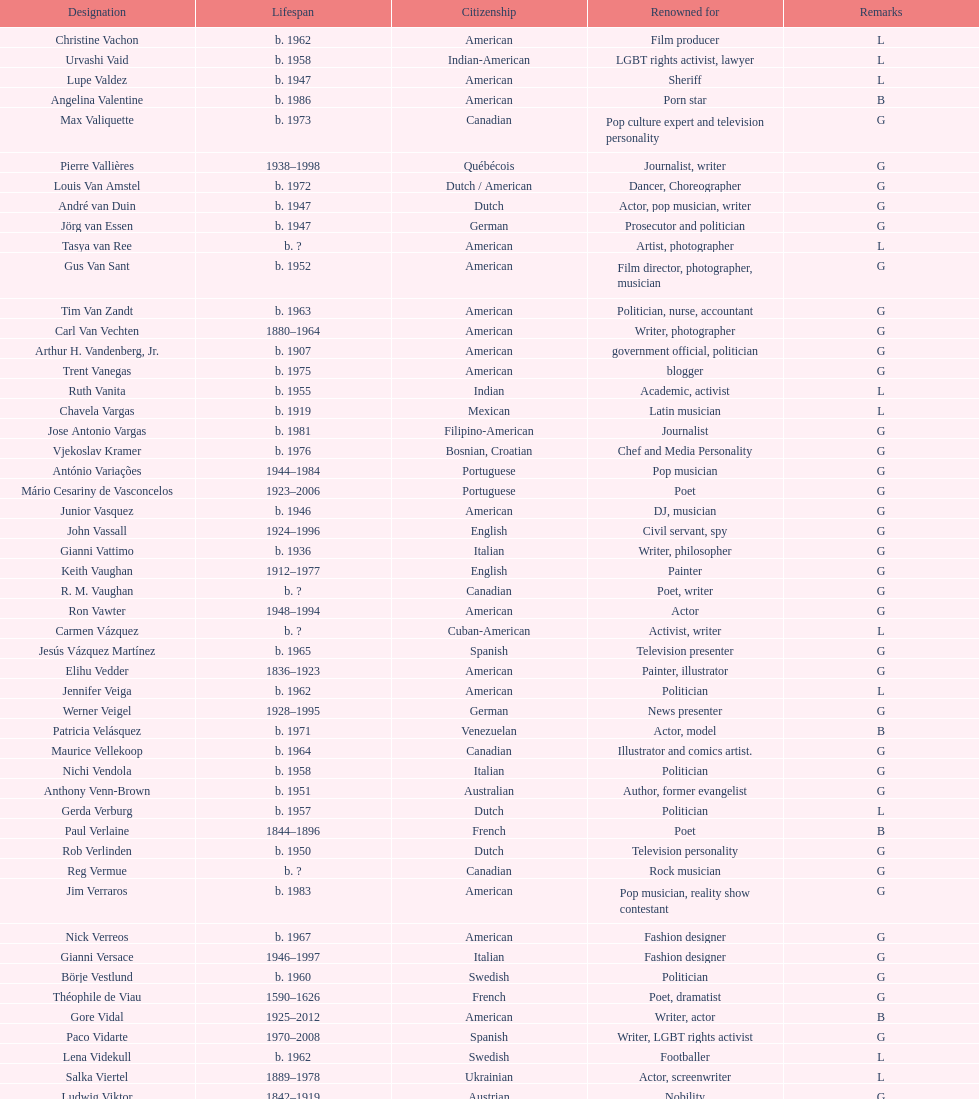Who lived longer, van vechten or variacoes? Van Vechten. 